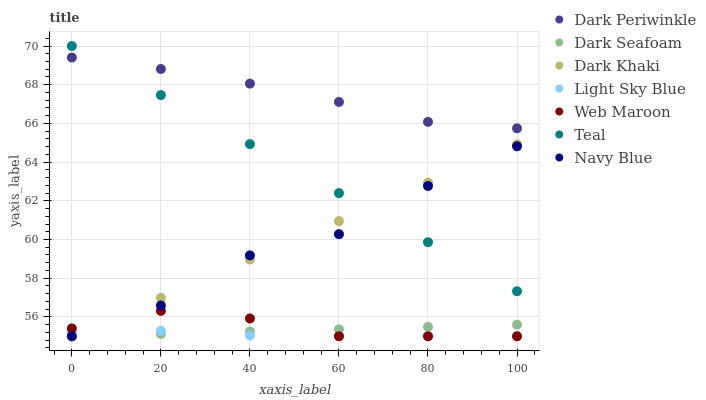Does Light Sky Blue have the minimum area under the curve?
Answer yes or no. Yes. Does Dark Periwinkle have the maximum area under the curve?
Answer yes or no. Yes. Does Web Maroon have the minimum area under the curve?
Answer yes or no. No. Does Web Maroon have the maximum area under the curve?
Answer yes or no. No. Is Dark Khaki the smoothest?
Answer yes or no. Yes. Is Navy Blue the roughest?
Answer yes or no. Yes. Is Web Maroon the smoothest?
Answer yes or no. No. Is Web Maroon the roughest?
Answer yes or no. No. Does Navy Blue have the lowest value?
Answer yes or no. Yes. Does Teal have the lowest value?
Answer yes or no. No. Does Teal have the highest value?
Answer yes or no. Yes. Does Web Maroon have the highest value?
Answer yes or no. No. Is Dark Seafoam less than Dark Periwinkle?
Answer yes or no. Yes. Is Teal greater than Light Sky Blue?
Answer yes or no. Yes. Does Dark Khaki intersect Web Maroon?
Answer yes or no. Yes. Is Dark Khaki less than Web Maroon?
Answer yes or no. No. Is Dark Khaki greater than Web Maroon?
Answer yes or no. No. Does Dark Seafoam intersect Dark Periwinkle?
Answer yes or no. No. 